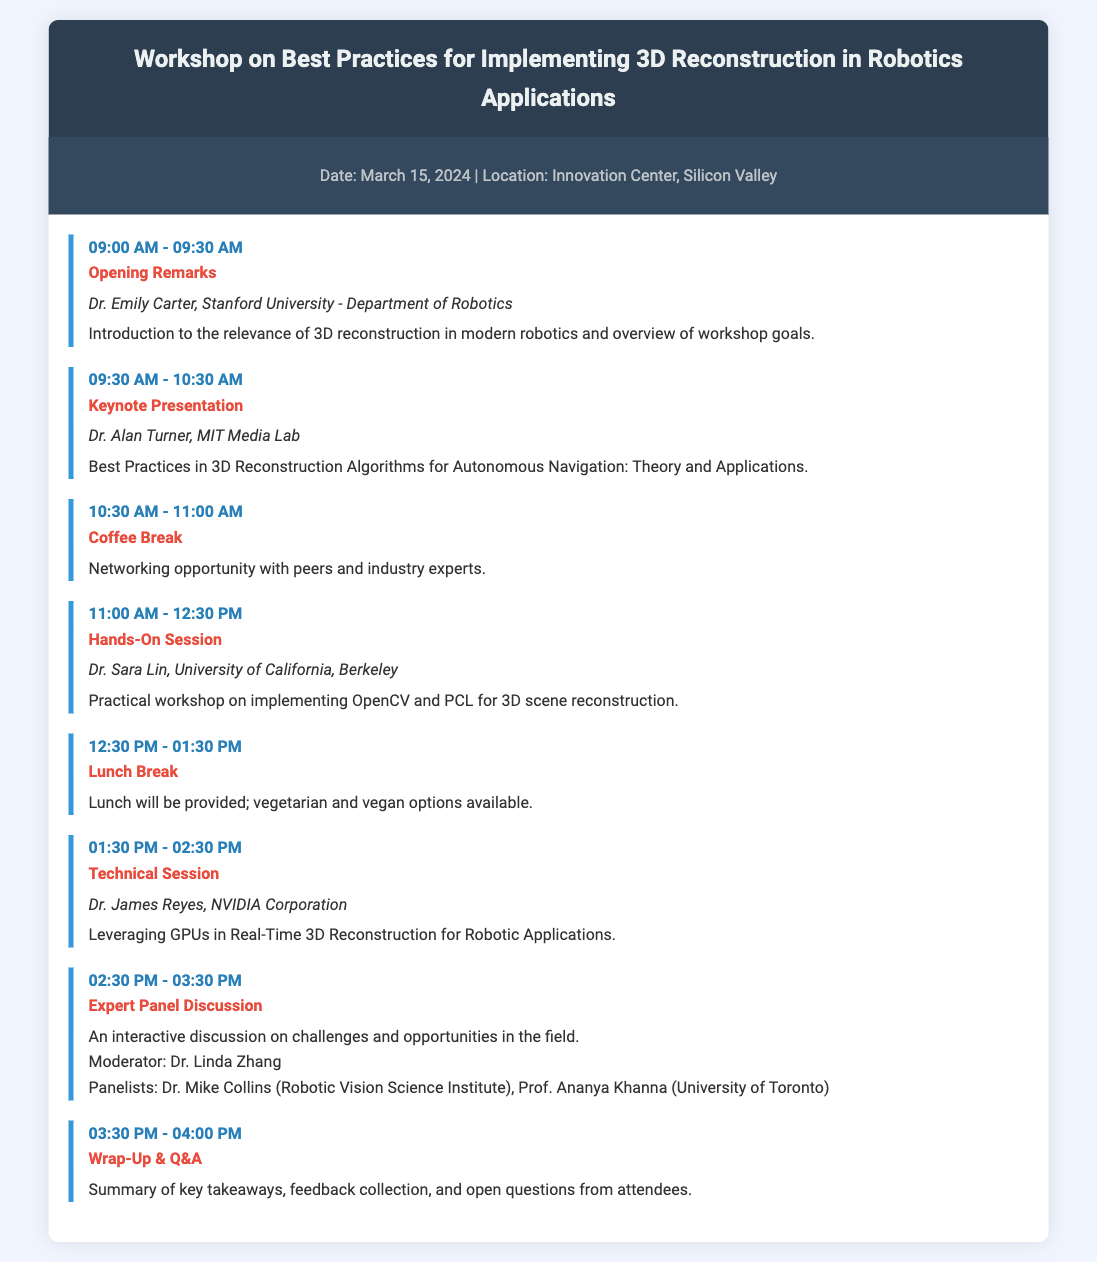What is the date of the workshop? The date is mentioned at the top of the document, specifically as March 15, 2024.
Answer: March 15, 2024 Who is the speaker for the Keynote Presentation? The document states that Dr. Alan Turner will be the speaker for the Keynote Presentation.
Answer: Dr. Alan Turner What time does the Hands-On Session start? The time for the Hands-On Session is clearly listed in the agenda, starting at 11:00 AM.
Answer: 11:00 AM How long is the Lunch Break? The Lunch Break is mentioned as lasting from 12:30 PM to 1:30 PM, which is a duration of one hour.
Answer: One hour Who is moderating the Expert Panel Discussion? The document indicates that Dr. Linda Zhang is the moderator for the Expert Panel Discussion.
Answer: Dr. Linda Zhang What is the main topic of Dr. Sara Lin's session? The description under Dr. Sara Lin's session indicates the main topic is practical implementation of OpenCV and PCL for 3D reconstruction.
Answer: OpenCV and PCL for 3D reconstruction What type of session is scheduled after the Coffee Break? The agenda lists a Hands-On Session following the Coffee Break.
Answer: Hands-On Session What is the focus of the Wrap-Up & Q&A session? The description suggests the focus is on summarizing key takeaways and collecting feedback from attendees.
Answer: Summary of key takeaways and feedback collection 